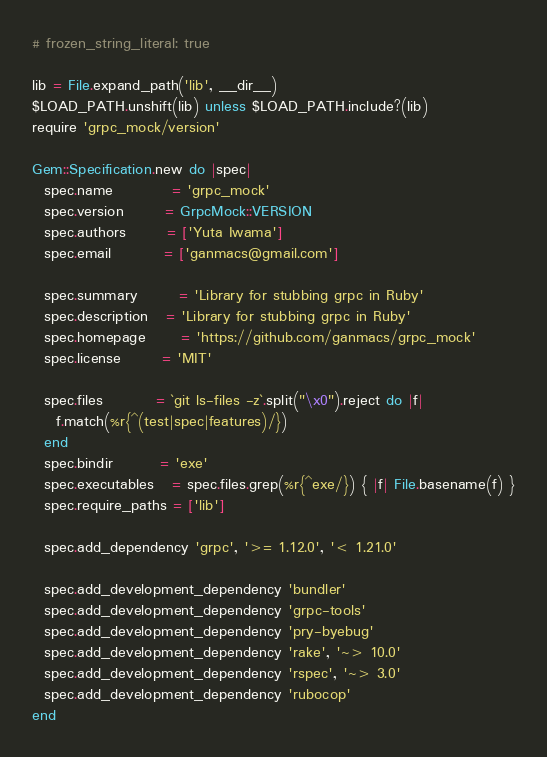Convert code to text. <code><loc_0><loc_0><loc_500><loc_500><_Ruby_># frozen_string_literal: true

lib = File.expand_path('lib', __dir__)
$LOAD_PATH.unshift(lib) unless $LOAD_PATH.include?(lib)
require 'grpc_mock/version'

Gem::Specification.new do |spec|
  spec.name          = 'grpc_mock'
  spec.version       = GrpcMock::VERSION
  spec.authors       = ['Yuta Iwama']
  spec.email         = ['ganmacs@gmail.com']

  spec.summary       = 'Library for stubbing grpc in Ruby'
  spec.description   = 'Library for stubbing grpc in Ruby'
  spec.homepage      = 'https://github.com/ganmacs/grpc_mock'
  spec.license       = 'MIT'

  spec.files         = `git ls-files -z`.split("\x0").reject do |f|
    f.match(%r{^(test|spec|features)/})
  end
  spec.bindir        = 'exe'
  spec.executables   = spec.files.grep(%r{^exe/}) { |f| File.basename(f) }
  spec.require_paths = ['lib']

  spec.add_dependency 'grpc', '>= 1.12.0', '< 1.21.0'

  spec.add_development_dependency 'bundler'
  spec.add_development_dependency 'grpc-tools'
  spec.add_development_dependency 'pry-byebug'
  spec.add_development_dependency 'rake', '~> 10.0'
  spec.add_development_dependency 'rspec', '~> 3.0'
  spec.add_development_dependency 'rubocop'
end
</code> 